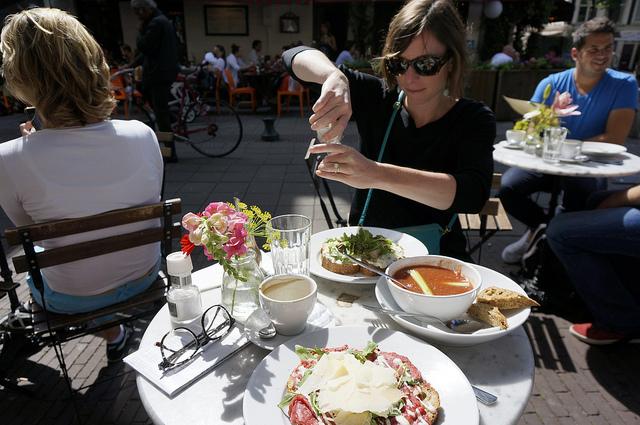Is this woman eating alone?
Give a very brief answer. No. Is the woman wearing a ring?
Be succinct. Yes. Is the woman cooking?
Short answer required. No. 